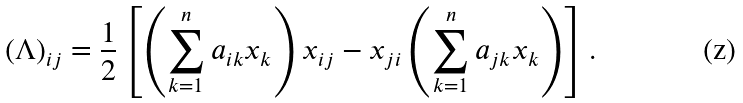<formula> <loc_0><loc_0><loc_500><loc_500>( \Lambda ) _ { i j } = \frac { 1 } { 2 } \left [ \left ( \sum _ { k = 1 } ^ { n } a _ { i k } x _ { k } \right ) x _ { i j } - x _ { j i } \left ( \sum _ { k = 1 } ^ { n } a _ { j k } x _ { k } \right ) \right ] .</formula> 